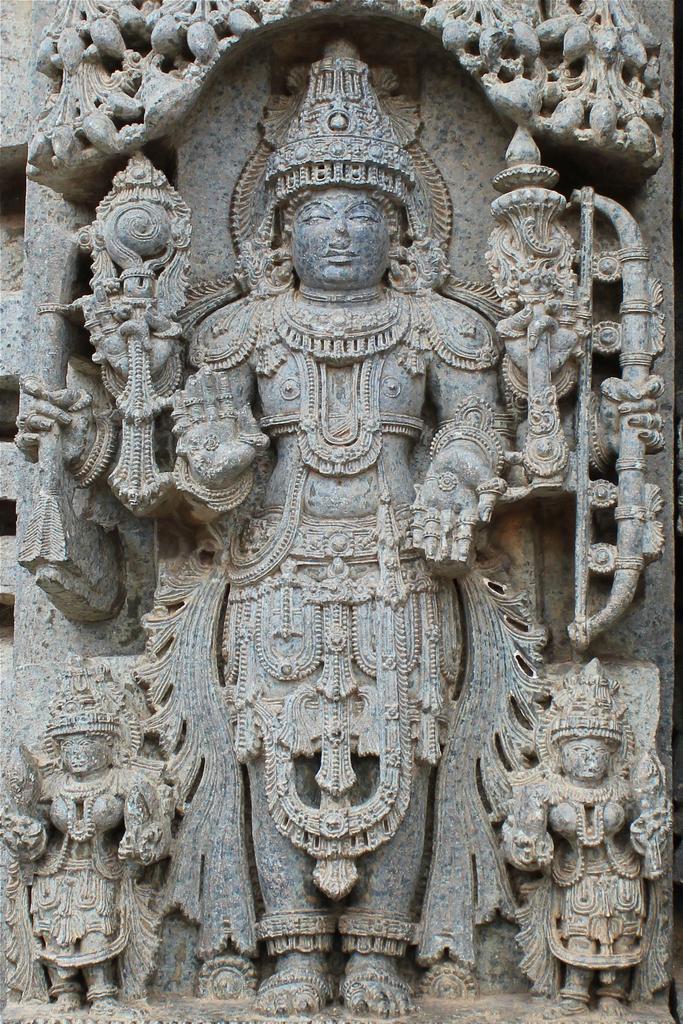Can you describe this image briefly? In this image there are a few sculptures and carvings on the wall. In the middle of the image there is a sculpture of a god. 